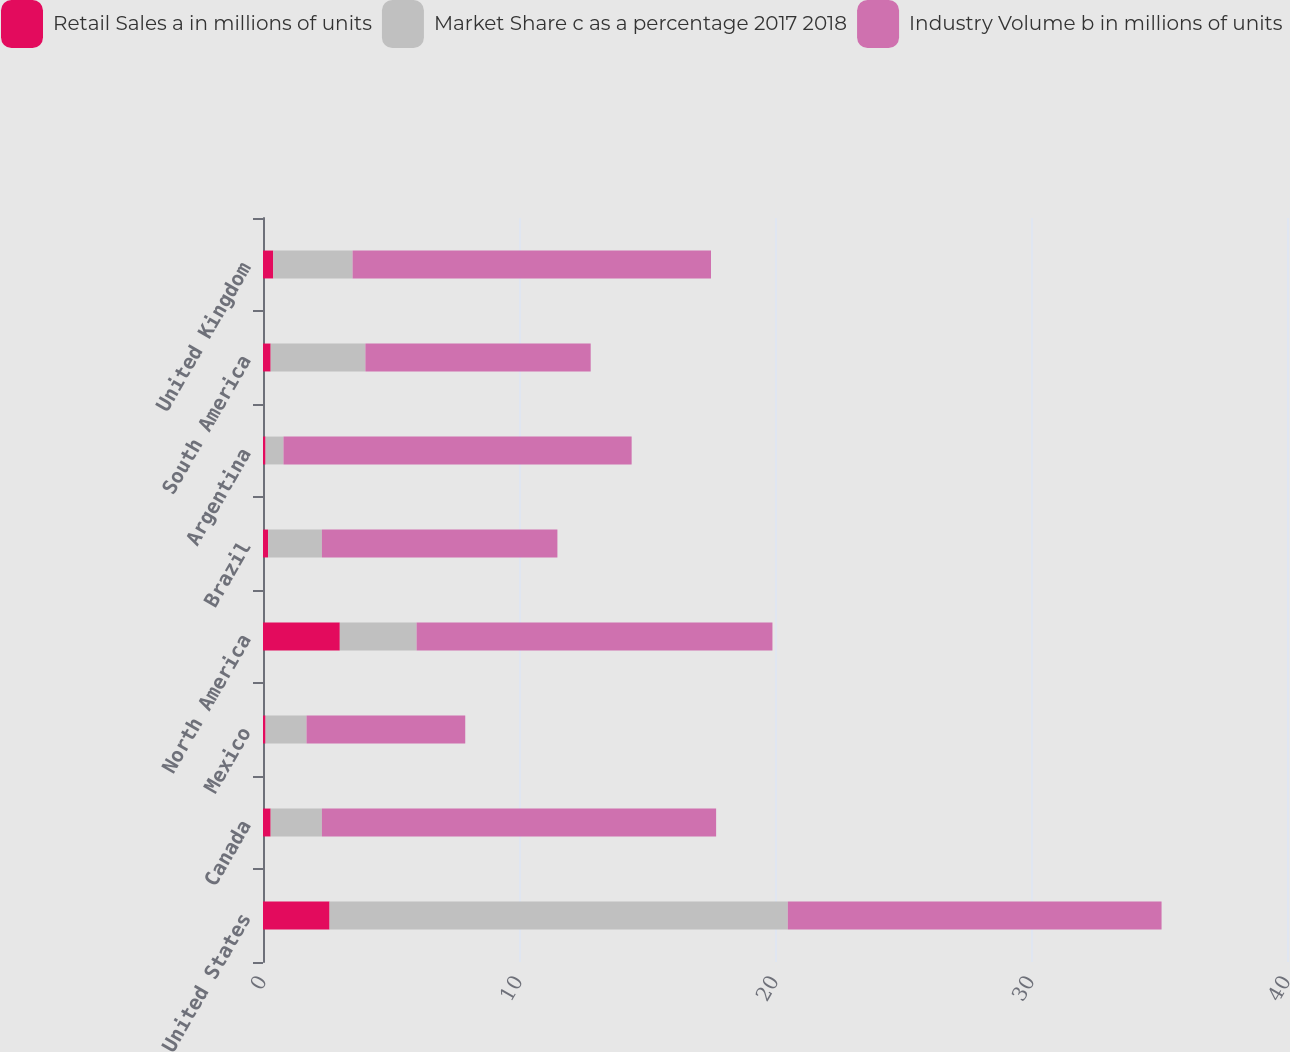Convert chart to OTSL. <chart><loc_0><loc_0><loc_500><loc_500><stacked_bar_chart><ecel><fcel>United States<fcel>Canada<fcel>Mexico<fcel>North America<fcel>Brazil<fcel>Argentina<fcel>South America<fcel>United Kingdom<nl><fcel>Retail Sales a in millions of units<fcel>2.6<fcel>0.3<fcel>0.1<fcel>3<fcel>0.2<fcel>0.1<fcel>0.3<fcel>0.4<nl><fcel>Market Share c as a percentage 2017 2018<fcel>17.9<fcel>2<fcel>1.6<fcel>3<fcel>2.1<fcel>0.7<fcel>3.7<fcel>3.1<nl><fcel>Industry Volume b in millions of units<fcel>14.6<fcel>15.4<fcel>6.2<fcel>13.9<fcel>9.2<fcel>13.6<fcel>8.8<fcel>14<nl></chart> 